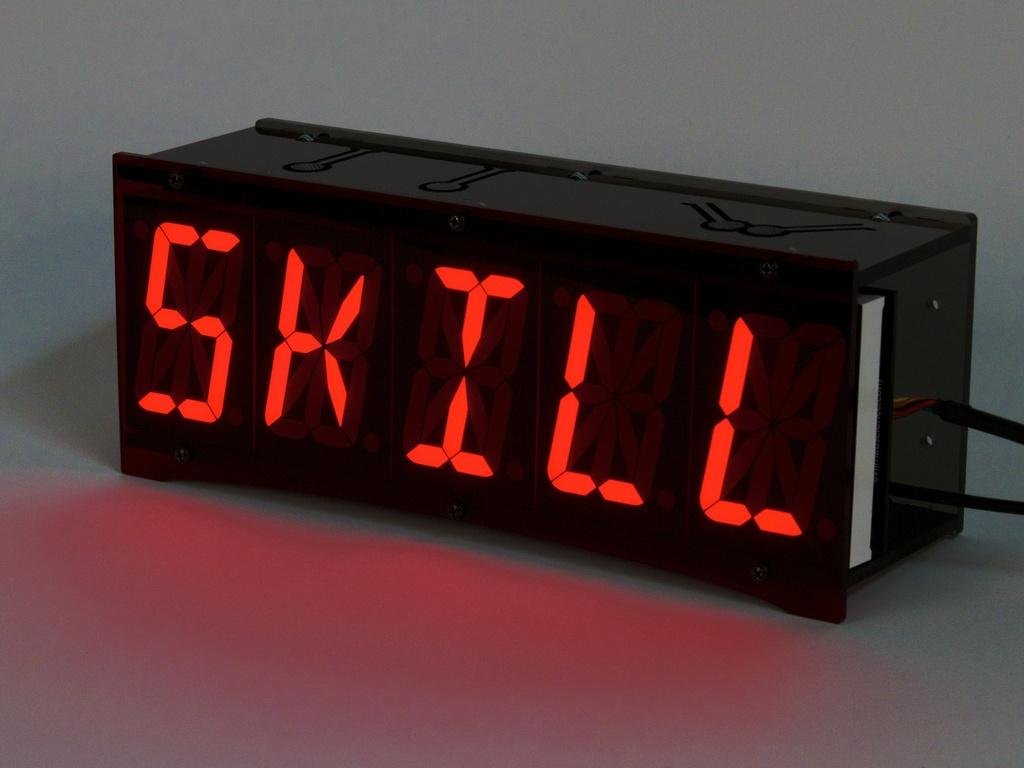<image>
Present a compact description of the photo's key features. A black digital clock displays the message SKILL in red letters. 